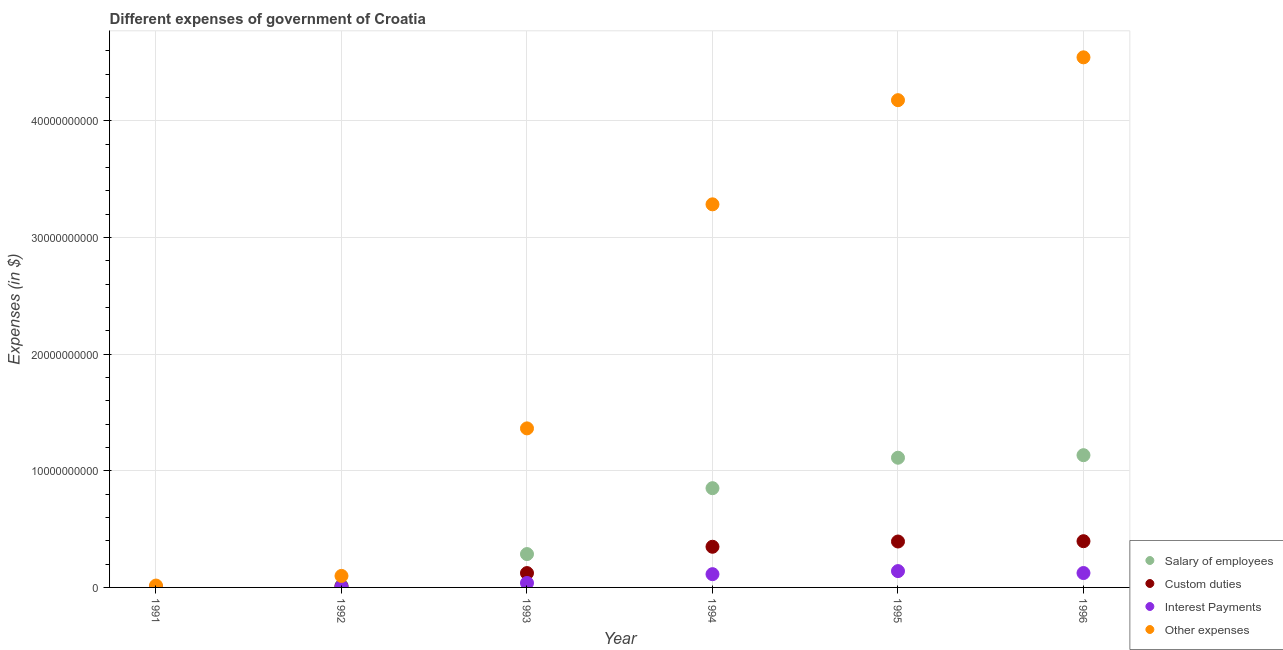How many different coloured dotlines are there?
Make the answer very short. 4. Is the number of dotlines equal to the number of legend labels?
Your answer should be compact. Yes. What is the amount spent on salary of employees in 1993?
Offer a very short reply. 2.86e+09. Across all years, what is the maximum amount spent on interest payments?
Keep it short and to the point. 1.40e+09. Across all years, what is the minimum amount spent on custom duties?
Your response must be concise. 5.01e+06. In which year was the amount spent on custom duties maximum?
Your answer should be very brief. 1996. What is the total amount spent on interest payments in the graph?
Offer a very short reply. 4.22e+09. What is the difference between the amount spent on other expenses in 1995 and that in 1996?
Offer a terse response. -3.67e+09. What is the difference between the amount spent on salary of employees in 1994 and the amount spent on custom duties in 1992?
Offer a very short reply. 8.41e+09. What is the average amount spent on other expenses per year?
Provide a short and direct response. 2.25e+1. In the year 1995, what is the difference between the amount spent on custom duties and amount spent on interest payments?
Your response must be concise. 2.54e+09. What is the ratio of the amount spent on salary of employees in 1994 to that in 1996?
Give a very brief answer. 0.75. Is the difference between the amount spent on other expenses in 1995 and 1996 greater than the difference between the amount spent on salary of employees in 1995 and 1996?
Your answer should be very brief. No. What is the difference between the highest and the second highest amount spent on custom duties?
Offer a terse response. 2.74e+07. What is the difference between the highest and the lowest amount spent on other expenses?
Ensure brevity in your answer.  4.53e+1. In how many years, is the amount spent on other expenses greater than the average amount spent on other expenses taken over all years?
Give a very brief answer. 3. Is the sum of the amount spent on salary of employees in 1992 and 1993 greater than the maximum amount spent on interest payments across all years?
Offer a terse response. Yes. Is it the case that in every year, the sum of the amount spent on salary of employees and amount spent on custom duties is greater than the amount spent on interest payments?
Your answer should be compact. Yes. Does the amount spent on salary of employees monotonically increase over the years?
Your answer should be compact. Yes. Is the amount spent on custom duties strictly less than the amount spent on salary of employees over the years?
Make the answer very short. Yes. How many years are there in the graph?
Your answer should be very brief. 6. Does the graph contain any zero values?
Provide a short and direct response. No. Where does the legend appear in the graph?
Make the answer very short. Bottom right. How are the legend labels stacked?
Keep it short and to the point. Vertical. What is the title of the graph?
Your answer should be compact. Different expenses of government of Croatia. What is the label or title of the X-axis?
Your response must be concise. Year. What is the label or title of the Y-axis?
Your response must be concise. Expenses (in $). What is the Expenses (in $) of Salary of employees in 1991?
Keep it short and to the point. 3.65e+07. What is the Expenses (in $) in Custom duties in 1991?
Provide a succinct answer. 5.01e+06. What is the Expenses (in $) of Interest Payments in 1991?
Offer a very short reply. 6.00e+05. What is the Expenses (in $) in Other expenses in 1991?
Make the answer very short. 1.61e+08. What is the Expenses (in $) in Salary of employees in 1992?
Your answer should be very brief. 1.59e+08. What is the Expenses (in $) in Custom duties in 1992?
Give a very brief answer. 9.94e+07. What is the Expenses (in $) of Interest Payments in 1992?
Your answer should be very brief. 6.43e+07. What is the Expenses (in $) in Other expenses in 1992?
Keep it short and to the point. 9.87e+08. What is the Expenses (in $) in Salary of employees in 1993?
Your response must be concise. 2.86e+09. What is the Expenses (in $) of Custom duties in 1993?
Give a very brief answer. 1.23e+09. What is the Expenses (in $) of Interest Payments in 1993?
Your response must be concise. 3.82e+08. What is the Expenses (in $) of Other expenses in 1993?
Provide a succinct answer. 1.36e+1. What is the Expenses (in $) of Salary of employees in 1994?
Keep it short and to the point. 8.51e+09. What is the Expenses (in $) of Custom duties in 1994?
Offer a very short reply. 3.49e+09. What is the Expenses (in $) of Interest Payments in 1994?
Offer a very short reply. 1.14e+09. What is the Expenses (in $) in Other expenses in 1994?
Your answer should be compact. 3.29e+1. What is the Expenses (in $) in Salary of employees in 1995?
Your answer should be compact. 1.11e+1. What is the Expenses (in $) in Custom duties in 1995?
Your answer should be very brief. 3.94e+09. What is the Expenses (in $) of Interest Payments in 1995?
Make the answer very short. 1.40e+09. What is the Expenses (in $) of Other expenses in 1995?
Keep it short and to the point. 4.18e+1. What is the Expenses (in $) of Salary of employees in 1996?
Provide a short and direct response. 1.13e+1. What is the Expenses (in $) of Custom duties in 1996?
Provide a short and direct response. 3.96e+09. What is the Expenses (in $) in Interest Payments in 1996?
Provide a succinct answer. 1.23e+09. What is the Expenses (in $) of Other expenses in 1996?
Make the answer very short. 4.55e+1. Across all years, what is the maximum Expenses (in $) in Salary of employees?
Keep it short and to the point. 1.13e+1. Across all years, what is the maximum Expenses (in $) in Custom duties?
Provide a short and direct response. 3.96e+09. Across all years, what is the maximum Expenses (in $) in Interest Payments?
Make the answer very short. 1.40e+09. Across all years, what is the maximum Expenses (in $) in Other expenses?
Provide a short and direct response. 4.55e+1. Across all years, what is the minimum Expenses (in $) in Salary of employees?
Your response must be concise. 3.65e+07. Across all years, what is the minimum Expenses (in $) in Custom duties?
Your answer should be compact. 5.01e+06. Across all years, what is the minimum Expenses (in $) of Other expenses?
Make the answer very short. 1.61e+08. What is the total Expenses (in $) in Salary of employees in the graph?
Ensure brevity in your answer.  3.40e+1. What is the total Expenses (in $) in Custom duties in the graph?
Ensure brevity in your answer.  1.27e+1. What is the total Expenses (in $) in Interest Payments in the graph?
Keep it short and to the point. 4.22e+09. What is the total Expenses (in $) of Other expenses in the graph?
Your response must be concise. 1.35e+11. What is the difference between the Expenses (in $) of Salary of employees in 1991 and that in 1992?
Your answer should be very brief. -1.23e+08. What is the difference between the Expenses (in $) in Custom duties in 1991 and that in 1992?
Provide a short and direct response. -9.44e+07. What is the difference between the Expenses (in $) in Interest Payments in 1991 and that in 1992?
Keep it short and to the point. -6.37e+07. What is the difference between the Expenses (in $) in Other expenses in 1991 and that in 1992?
Make the answer very short. -8.26e+08. What is the difference between the Expenses (in $) of Salary of employees in 1991 and that in 1993?
Provide a succinct answer. -2.82e+09. What is the difference between the Expenses (in $) in Custom duties in 1991 and that in 1993?
Offer a terse response. -1.23e+09. What is the difference between the Expenses (in $) in Interest Payments in 1991 and that in 1993?
Give a very brief answer. -3.81e+08. What is the difference between the Expenses (in $) of Other expenses in 1991 and that in 1993?
Make the answer very short. -1.35e+1. What is the difference between the Expenses (in $) of Salary of employees in 1991 and that in 1994?
Offer a very short reply. -8.47e+09. What is the difference between the Expenses (in $) of Custom duties in 1991 and that in 1994?
Give a very brief answer. -3.48e+09. What is the difference between the Expenses (in $) in Interest Payments in 1991 and that in 1994?
Ensure brevity in your answer.  -1.14e+09. What is the difference between the Expenses (in $) in Other expenses in 1991 and that in 1994?
Your answer should be very brief. -3.27e+1. What is the difference between the Expenses (in $) of Salary of employees in 1991 and that in 1995?
Your response must be concise. -1.11e+1. What is the difference between the Expenses (in $) of Custom duties in 1991 and that in 1995?
Keep it short and to the point. -3.93e+09. What is the difference between the Expenses (in $) of Interest Payments in 1991 and that in 1995?
Make the answer very short. -1.40e+09. What is the difference between the Expenses (in $) in Other expenses in 1991 and that in 1995?
Provide a succinct answer. -4.16e+1. What is the difference between the Expenses (in $) in Salary of employees in 1991 and that in 1996?
Offer a terse response. -1.13e+1. What is the difference between the Expenses (in $) of Custom duties in 1991 and that in 1996?
Keep it short and to the point. -3.96e+09. What is the difference between the Expenses (in $) in Interest Payments in 1991 and that in 1996?
Make the answer very short. -1.23e+09. What is the difference between the Expenses (in $) in Other expenses in 1991 and that in 1996?
Ensure brevity in your answer.  -4.53e+1. What is the difference between the Expenses (in $) of Salary of employees in 1992 and that in 1993?
Ensure brevity in your answer.  -2.70e+09. What is the difference between the Expenses (in $) in Custom duties in 1992 and that in 1993?
Give a very brief answer. -1.13e+09. What is the difference between the Expenses (in $) in Interest Payments in 1992 and that in 1993?
Provide a short and direct response. -3.18e+08. What is the difference between the Expenses (in $) in Other expenses in 1992 and that in 1993?
Offer a very short reply. -1.27e+1. What is the difference between the Expenses (in $) in Salary of employees in 1992 and that in 1994?
Your response must be concise. -8.35e+09. What is the difference between the Expenses (in $) of Custom duties in 1992 and that in 1994?
Your response must be concise. -3.39e+09. What is the difference between the Expenses (in $) in Interest Payments in 1992 and that in 1994?
Make the answer very short. -1.07e+09. What is the difference between the Expenses (in $) of Other expenses in 1992 and that in 1994?
Make the answer very short. -3.19e+1. What is the difference between the Expenses (in $) of Salary of employees in 1992 and that in 1995?
Give a very brief answer. -1.10e+1. What is the difference between the Expenses (in $) of Custom duties in 1992 and that in 1995?
Offer a terse response. -3.84e+09. What is the difference between the Expenses (in $) of Interest Payments in 1992 and that in 1995?
Your answer should be compact. -1.34e+09. What is the difference between the Expenses (in $) of Other expenses in 1992 and that in 1995?
Give a very brief answer. -4.08e+1. What is the difference between the Expenses (in $) in Salary of employees in 1992 and that in 1996?
Offer a terse response. -1.12e+1. What is the difference between the Expenses (in $) of Custom duties in 1992 and that in 1996?
Your response must be concise. -3.87e+09. What is the difference between the Expenses (in $) of Interest Payments in 1992 and that in 1996?
Your response must be concise. -1.17e+09. What is the difference between the Expenses (in $) in Other expenses in 1992 and that in 1996?
Offer a terse response. -4.45e+1. What is the difference between the Expenses (in $) of Salary of employees in 1993 and that in 1994?
Offer a terse response. -5.65e+09. What is the difference between the Expenses (in $) of Custom duties in 1993 and that in 1994?
Offer a terse response. -2.26e+09. What is the difference between the Expenses (in $) in Interest Payments in 1993 and that in 1994?
Provide a short and direct response. -7.55e+08. What is the difference between the Expenses (in $) of Other expenses in 1993 and that in 1994?
Provide a succinct answer. -1.92e+1. What is the difference between the Expenses (in $) of Salary of employees in 1993 and that in 1995?
Keep it short and to the point. -8.26e+09. What is the difference between the Expenses (in $) of Custom duties in 1993 and that in 1995?
Your response must be concise. -2.71e+09. What is the difference between the Expenses (in $) in Interest Payments in 1993 and that in 1995?
Give a very brief answer. -1.02e+09. What is the difference between the Expenses (in $) in Other expenses in 1993 and that in 1995?
Provide a short and direct response. -2.81e+1. What is the difference between the Expenses (in $) in Salary of employees in 1993 and that in 1996?
Your response must be concise. -8.48e+09. What is the difference between the Expenses (in $) of Custom duties in 1993 and that in 1996?
Your response must be concise. -2.73e+09. What is the difference between the Expenses (in $) in Interest Payments in 1993 and that in 1996?
Your answer should be compact. -8.53e+08. What is the difference between the Expenses (in $) in Other expenses in 1993 and that in 1996?
Keep it short and to the point. -3.18e+1. What is the difference between the Expenses (in $) in Salary of employees in 1994 and that in 1995?
Your response must be concise. -2.61e+09. What is the difference between the Expenses (in $) of Custom duties in 1994 and that in 1995?
Your response must be concise. -4.51e+08. What is the difference between the Expenses (in $) of Interest Payments in 1994 and that in 1995?
Provide a short and direct response. -2.63e+08. What is the difference between the Expenses (in $) of Other expenses in 1994 and that in 1995?
Ensure brevity in your answer.  -8.93e+09. What is the difference between the Expenses (in $) in Salary of employees in 1994 and that in 1996?
Your answer should be compact. -2.83e+09. What is the difference between the Expenses (in $) in Custom duties in 1994 and that in 1996?
Provide a short and direct response. -4.78e+08. What is the difference between the Expenses (in $) in Interest Payments in 1994 and that in 1996?
Your answer should be compact. -9.75e+07. What is the difference between the Expenses (in $) of Other expenses in 1994 and that in 1996?
Your response must be concise. -1.26e+1. What is the difference between the Expenses (in $) of Salary of employees in 1995 and that in 1996?
Keep it short and to the point. -2.18e+08. What is the difference between the Expenses (in $) in Custom duties in 1995 and that in 1996?
Provide a succinct answer. -2.74e+07. What is the difference between the Expenses (in $) in Interest Payments in 1995 and that in 1996?
Ensure brevity in your answer.  1.66e+08. What is the difference between the Expenses (in $) in Other expenses in 1995 and that in 1996?
Ensure brevity in your answer.  -3.67e+09. What is the difference between the Expenses (in $) in Salary of employees in 1991 and the Expenses (in $) in Custom duties in 1992?
Ensure brevity in your answer.  -6.29e+07. What is the difference between the Expenses (in $) in Salary of employees in 1991 and the Expenses (in $) in Interest Payments in 1992?
Give a very brief answer. -2.78e+07. What is the difference between the Expenses (in $) of Salary of employees in 1991 and the Expenses (in $) of Other expenses in 1992?
Your answer should be very brief. -9.50e+08. What is the difference between the Expenses (in $) in Custom duties in 1991 and the Expenses (in $) in Interest Payments in 1992?
Your answer should be compact. -5.93e+07. What is the difference between the Expenses (in $) in Custom duties in 1991 and the Expenses (in $) in Other expenses in 1992?
Provide a short and direct response. -9.82e+08. What is the difference between the Expenses (in $) of Interest Payments in 1991 and the Expenses (in $) of Other expenses in 1992?
Offer a very short reply. -9.86e+08. What is the difference between the Expenses (in $) in Salary of employees in 1991 and the Expenses (in $) in Custom duties in 1993?
Offer a terse response. -1.19e+09. What is the difference between the Expenses (in $) in Salary of employees in 1991 and the Expenses (in $) in Interest Payments in 1993?
Provide a succinct answer. -3.45e+08. What is the difference between the Expenses (in $) in Salary of employees in 1991 and the Expenses (in $) in Other expenses in 1993?
Offer a very short reply. -1.36e+1. What is the difference between the Expenses (in $) in Custom duties in 1991 and the Expenses (in $) in Interest Payments in 1993?
Make the answer very short. -3.77e+08. What is the difference between the Expenses (in $) in Custom duties in 1991 and the Expenses (in $) in Other expenses in 1993?
Your answer should be very brief. -1.36e+1. What is the difference between the Expenses (in $) of Interest Payments in 1991 and the Expenses (in $) of Other expenses in 1993?
Provide a succinct answer. -1.36e+1. What is the difference between the Expenses (in $) in Salary of employees in 1991 and the Expenses (in $) in Custom duties in 1994?
Your answer should be very brief. -3.45e+09. What is the difference between the Expenses (in $) in Salary of employees in 1991 and the Expenses (in $) in Interest Payments in 1994?
Keep it short and to the point. -1.10e+09. What is the difference between the Expenses (in $) in Salary of employees in 1991 and the Expenses (in $) in Other expenses in 1994?
Keep it short and to the point. -3.28e+1. What is the difference between the Expenses (in $) in Custom duties in 1991 and the Expenses (in $) in Interest Payments in 1994?
Your answer should be compact. -1.13e+09. What is the difference between the Expenses (in $) in Custom duties in 1991 and the Expenses (in $) in Other expenses in 1994?
Your response must be concise. -3.28e+1. What is the difference between the Expenses (in $) in Interest Payments in 1991 and the Expenses (in $) in Other expenses in 1994?
Your response must be concise. -3.29e+1. What is the difference between the Expenses (in $) of Salary of employees in 1991 and the Expenses (in $) of Custom duties in 1995?
Make the answer very short. -3.90e+09. What is the difference between the Expenses (in $) of Salary of employees in 1991 and the Expenses (in $) of Interest Payments in 1995?
Your answer should be very brief. -1.36e+09. What is the difference between the Expenses (in $) of Salary of employees in 1991 and the Expenses (in $) of Other expenses in 1995?
Keep it short and to the point. -4.17e+1. What is the difference between the Expenses (in $) in Custom duties in 1991 and the Expenses (in $) in Interest Payments in 1995?
Your response must be concise. -1.40e+09. What is the difference between the Expenses (in $) in Custom duties in 1991 and the Expenses (in $) in Other expenses in 1995?
Offer a terse response. -4.18e+1. What is the difference between the Expenses (in $) of Interest Payments in 1991 and the Expenses (in $) of Other expenses in 1995?
Provide a succinct answer. -4.18e+1. What is the difference between the Expenses (in $) in Salary of employees in 1991 and the Expenses (in $) in Custom duties in 1996?
Your answer should be very brief. -3.93e+09. What is the difference between the Expenses (in $) in Salary of employees in 1991 and the Expenses (in $) in Interest Payments in 1996?
Your response must be concise. -1.20e+09. What is the difference between the Expenses (in $) of Salary of employees in 1991 and the Expenses (in $) of Other expenses in 1996?
Provide a succinct answer. -4.54e+1. What is the difference between the Expenses (in $) of Custom duties in 1991 and the Expenses (in $) of Interest Payments in 1996?
Ensure brevity in your answer.  -1.23e+09. What is the difference between the Expenses (in $) in Custom duties in 1991 and the Expenses (in $) in Other expenses in 1996?
Provide a short and direct response. -4.55e+1. What is the difference between the Expenses (in $) in Interest Payments in 1991 and the Expenses (in $) in Other expenses in 1996?
Give a very brief answer. -4.55e+1. What is the difference between the Expenses (in $) in Salary of employees in 1992 and the Expenses (in $) in Custom duties in 1993?
Your answer should be very brief. -1.07e+09. What is the difference between the Expenses (in $) in Salary of employees in 1992 and the Expenses (in $) in Interest Payments in 1993?
Your answer should be compact. -2.23e+08. What is the difference between the Expenses (in $) of Salary of employees in 1992 and the Expenses (in $) of Other expenses in 1993?
Your answer should be very brief. -1.35e+1. What is the difference between the Expenses (in $) in Custom duties in 1992 and the Expenses (in $) in Interest Payments in 1993?
Offer a terse response. -2.82e+08. What is the difference between the Expenses (in $) in Custom duties in 1992 and the Expenses (in $) in Other expenses in 1993?
Ensure brevity in your answer.  -1.35e+1. What is the difference between the Expenses (in $) in Interest Payments in 1992 and the Expenses (in $) in Other expenses in 1993?
Make the answer very short. -1.36e+1. What is the difference between the Expenses (in $) in Salary of employees in 1992 and the Expenses (in $) in Custom duties in 1994?
Keep it short and to the point. -3.33e+09. What is the difference between the Expenses (in $) in Salary of employees in 1992 and the Expenses (in $) in Interest Payments in 1994?
Provide a short and direct response. -9.78e+08. What is the difference between the Expenses (in $) in Salary of employees in 1992 and the Expenses (in $) in Other expenses in 1994?
Your answer should be very brief. -3.27e+1. What is the difference between the Expenses (in $) in Custom duties in 1992 and the Expenses (in $) in Interest Payments in 1994?
Give a very brief answer. -1.04e+09. What is the difference between the Expenses (in $) in Custom duties in 1992 and the Expenses (in $) in Other expenses in 1994?
Make the answer very short. -3.28e+1. What is the difference between the Expenses (in $) of Interest Payments in 1992 and the Expenses (in $) of Other expenses in 1994?
Offer a terse response. -3.28e+1. What is the difference between the Expenses (in $) in Salary of employees in 1992 and the Expenses (in $) in Custom duties in 1995?
Your response must be concise. -3.78e+09. What is the difference between the Expenses (in $) in Salary of employees in 1992 and the Expenses (in $) in Interest Payments in 1995?
Your answer should be compact. -1.24e+09. What is the difference between the Expenses (in $) in Salary of employees in 1992 and the Expenses (in $) in Other expenses in 1995?
Make the answer very short. -4.16e+1. What is the difference between the Expenses (in $) of Custom duties in 1992 and the Expenses (in $) of Interest Payments in 1995?
Provide a short and direct response. -1.30e+09. What is the difference between the Expenses (in $) of Custom duties in 1992 and the Expenses (in $) of Other expenses in 1995?
Your answer should be very brief. -4.17e+1. What is the difference between the Expenses (in $) of Interest Payments in 1992 and the Expenses (in $) of Other expenses in 1995?
Provide a succinct answer. -4.17e+1. What is the difference between the Expenses (in $) of Salary of employees in 1992 and the Expenses (in $) of Custom duties in 1996?
Make the answer very short. -3.81e+09. What is the difference between the Expenses (in $) of Salary of employees in 1992 and the Expenses (in $) of Interest Payments in 1996?
Provide a short and direct response. -1.08e+09. What is the difference between the Expenses (in $) of Salary of employees in 1992 and the Expenses (in $) of Other expenses in 1996?
Provide a short and direct response. -4.53e+1. What is the difference between the Expenses (in $) of Custom duties in 1992 and the Expenses (in $) of Interest Payments in 1996?
Your answer should be very brief. -1.14e+09. What is the difference between the Expenses (in $) of Custom duties in 1992 and the Expenses (in $) of Other expenses in 1996?
Give a very brief answer. -4.54e+1. What is the difference between the Expenses (in $) in Interest Payments in 1992 and the Expenses (in $) in Other expenses in 1996?
Keep it short and to the point. -4.54e+1. What is the difference between the Expenses (in $) in Salary of employees in 1993 and the Expenses (in $) in Custom duties in 1994?
Your response must be concise. -6.27e+08. What is the difference between the Expenses (in $) in Salary of employees in 1993 and the Expenses (in $) in Interest Payments in 1994?
Keep it short and to the point. 1.72e+09. What is the difference between the Expenses (in $) in Salary of employees in 1993 and the Expenses (in $) in Other expenses in 1994?
Keep it short and to the point. -3.00e+1. What is the difference between the Expenses (in $) of Custom duties in 1993 and the Expenses (in $) of Interest Payments in 1994?
Offer a very short reply. 9.32e+07. What is the difference between the Expenses (in $) in Custom duties in 1993 and the Expenses (in $) in Other expenses in 1994?
Offer a very short reply. -3.16e+1. What is the difference between the Expenses (in $) in Interest Payments in 1993 and the Expenses (in $) in Other expenses in 1994?
Your answer should be very brief. -3.25e+1. What is the difference between the Expenses (in $) of Salary of employees in 1993 and the Expenses (in $) of Custom duties in 1995?
Provide a succinct answer. -1.08e+09. What is the difference between the Expenses (in $) of Salary of employees in 1993 and the Expenses (in $) of Interest Payments in 1995?
Offer a terse response. 1.46e+09. What is the difference between the Expenses (in $) in Salary of employees in 1993 and the Expenses (in $) in Other expenses in 1995?
Your response must be concise. -3.89e+1. What is the difference between the Expenses (in $) of Custom duties in 1993 and the Expenses (in $) of Interest Payments in 1995?
Make the answer very short. -1.70e+08. What is the difference between the Expenses (in $) in Custom duties in 1993 and the Expenses (in $) in Other expenses in 1995?
Make the answer very short. -4.06e+1. What is the difference between the Expenses (in $) in Interest Payments in 1993 and the Expenses (in $) in Other expenses in 1995?
Your answer should be compact. -4.14e+1. What is the difference between the Expenses (in $) of Salary of employees in 1993 and the Expenses (in $) of Custom duties in 1996?
Make the answer very short. -1.10e+09. What is the difference between the Expenses (in $) of Salary of employees in 1993 and the Expenses (in $) of Interest Payments in 1996?
Your answer should be very brief. 1.63e+09. What is the difference between the Expenses (in $) of Salary of employees in 1993 and the Expenses (in $) of Other expenses in 1996?
Offer a very short reply. -4.26e+1. What is the difference between the Expenses (in $) in Custom duties in 1993 and the Expenses (in $) in Interest Payments in 1996?
Your response must be concise. -4.30e+06. What is the difference between the Expenses (in $) of Custom duties in 1993 and the Expenses (in $) of Other expenses in 1996?
Keep it short and to the point. -4.42e+1. What is the difference between the Expenses (in $) in Interest Payments in 1993 and the Expenses (in $) in Other expenses in 1996?
Make the answer very short. -4.51e+1. What is the difference between the Expenses (in $) of Salary of employees in 1994 and the Expenses (in $) of Custom duties in 1995?
Give a very brief answer. 4.57e+09. What is the difference between the Expenses (in $) of Salary of employees in 1994 and the Expenses (in $) of Interest Payments in 1995?
Provide a succinct answer. 7.11e+09. What is the difference between the Expenses (in $) in Salary of employees in 1994 and the Expenses (in $) in Other expenses in 1995?
Make the answer very short. -3.33e+1. What is the difference between the Expenses (in $) in Custom duties in 1994 and the Expenses (in $) in Interest Payments in 1995?
Give a very brief answer. 2.09e+09. What is the difference between the Expenses (in $) of Custom duties in 1994 and the Expenses (in $) of Other expenses in 1995?
Your answer should be compact. -3.83e+1. What is the difference between the Expenses (in $) in Interest Payments in 1994 and the Expenses (in $) in Other expenses in 1995?
Your response must be concise. -4.06e+1. What is the difference between the Expenses (in $) in Salary of employees in 1994 and the Expenses (in $) in Custom duties in 1996?
Offer a very short reply. 4.55e+09. What is the difference between the Expenses (in $) in Salary of employees in 1994 and the Expenses (in $) in Interest Payments in 1996?
Your response must be concise. 7.28e+09. What is the difference between the Expenses (in $) in Salary of employees in 1994 and the Expenses (in $) in Other expenses in 1996?
Your response must be concise. -3.69e+1. What is the difference between the Expenses (in $) of Custom duties in 1994 and the Expenses (in $) of Interest Payments in 1996?
Keep it short and to the point. 2.25e+09. What is the difference between the Expenses (in $) of Custom duties in 1994 and the Expenses (in $) of Other expenses in 1996?
Give a very brief answer. -4.20e+1. What is the difference between the Expenses (in $) in Interest Payments in 1994 and the Expenses (in $) in Other expenses in 1996?
Your response must be concise. -4.43e+1. What is the difference between the Expenses (in $) of Salary of employees in 1995 and the Expenses (in $) of Custom duties in 1996?
Your answer should be very brief. 7.16e+09. What is the difference between the Expenses (in $) in Salary of employees in 1995 and the Expenses (in $) in Interest Payments in 1996?
Your answer should be very brief. 9.89e+09. What is the difference between the Expenses (in $) in Salary of employees in 1995 and the Expenses (in $) in Other expenses in 1996?
Your answer should be compact. -3.43e+1. What is the difference between the Expenses (in $) of Custom duties in 1995 and the Expenses (in $) of Interest Payments in 1996?
Your response must be concise. 2.70e+09. What is the difference between the Expenses (in $) of Custom duties in 1995 and the Expenses (in $) of Other expenses in 1996?
Provide a short and direct response. -4.15e+1. What is the difference between the Expenses (in $) in Interest Payments in 1995 and the Expenses (in $) in Other expenses in 1996?
Your answer should be very brief. -4.41e+1. What is the average Expenses (in $) in Salary of employees per year?
Make the answer very short. 5.67e+09. What is the average Expenses (in $) of Custom duties per year?
Your answer should be compact. 2.12e+09. What is the average Expenses (in $) of Interest Payments per year?
Ensure brevity in your answer.  7.03e+08. What is the average Expenses (in $) in Other expenses per year?
Give a very brief answer. 2.25e+1. In the year 1991, what is the difference between the Expenses (in $) in Salary of employees and Expenses (in $) in Custom duties?
Your response must be concise. 3.15e+07. In the year 1991, what is the difference between the Expenses (in $) in Salary of employees and Expenses (in $) in Interest Payments?
Your answer should be very brief. 3.59e+07. In the year 1991, what is the difference between the Expenses (in $) in Salary of employees and Expenses (in $) in Other expenses?
Provide a short and direct response. -1.24e+08. In the year 1991, what is the difference between the Expenses (in $) in Custom duties and Expenses (in $) in Interest Payments?
Give a very brief answer. 4.41e+06. In the year 1991, what is the difference between the Expenses (in $) of Custom duties and Expenses (in $) of Other expenses?
Offer a terse response. -1.56e+08. In the year 1991, what is the difference between the Expenses (in $) in Interest Payments and Expenses (in $) in Other expenses?
Offer a very short reply. -1.60e+08. In the year 1992, what is the difference between the Expenses (in $) in Salary of employees and Expenses (in $) in Custom duties?
Make the answer very short. 5.98e+07. In the year 1992, what is the difference between the Expenses (in $) of Salary of employees and Expenses (in $) of Interest Payments?
Give a very brief answer. 9.49e+07. In the year 1992, what is the difference between the Expenses (in $) of Salary of employees and Expenses (in $) of Other expenses?
Offer a very short reply. -8.28e+08. In the year 1992, what is the difference between the Expenses (in $) in Custom duties and Expenses (in $) in Interest Payments?
Offer a very short reply. 3.52e+07. In the year 1992, what is the difference between the Expenses (in $) in Custom duties and Expenses (in $) in Other expenses?
Your answer should be very brief. -8.87e+08. In the year 1992, what is the difference between the Expenses (in $) in Interest Payments and Expenses (in $) in Other expenses?
Ensure brevity in your answer.  -9.22e+08. In the year 1993, what is the difference between the Expenses (in $) of Salary of employees and Expenses (in $) of Custom duties?
Your response must be concise. 1.63e+09. In the year 1993, what is the difference between the Expenses (in $) in Salary of employees and Expenses (in $) in Interest Payments?
Offer a terse response. 2.48e+09. In the year 1993, what is the difference between the Expenses (in $) in Salary of employees and Expenses (in $) in Other expenses?
Provide a succinct answer. -1.08e+1. In the year 1993, what is the difference between the Expenses (in $) in Custom duties and Expenses (in $) in Interest Payments?
Your answer should be compact. 8.48e+08. In the year 1993, what is the difference between the Expenses (in $) in Custom duties and Expenses (in $) in Other expenses?
Make the answer very short. -1.24e+1. In the year 1993, what is the difference between the Expenses (in $) of Interest Payments and Expenses (in $) of Other expenses?
Make the answer very short. -1.33e+1. In the year 1994, what is the difference between the Expenses (in $) in Salary of employees and Expenses (in $) in Custom duties?
Your answer should be compact. 5.02e+09. In the year 1994, what is the difference between the Expenses (in $) of Salary of employees and Expenses (in $) of Interest Payments?
Make the answer very short. 7.37e+09. In the year 1994, what is the difference between the Expenses (in $) of Salary of employees and Expenses (in $) of Other expenses?
Your response must be concise. -2.43e+1. In the year 1994, what is the difference between the Expenses (in $) in Custom duties and Expenses (in $) in Interest Payments?
Make the answer very short. 2.35e+09. In the year 1994, what is the difference between the Expenses (in $) of Custom duties and Expenses (in $) of Other expenses?
Offer a terse response. -2.94e+1. In the year 1994, what is the difference between the Expenses (in $) in Interest Payments and Expenses (in $) in Other expenses?
Give a very brief answer. -3.17e+1. In the year 1995, what is the difference between the Expenses (in $) in Salary of employees and Expenses (in $) in Custom duties?
Offer a terse response. 7.18e+09. In the year 1995, what is the difference between the Expenses (in $) in Salary of employees and Expenses (in $) in Interest Payments?
Your response must be concise. 9.72e+09. In the year 1995, what is the difference between the Expenses (in $) in Salary of employees and Expenses (in $) in Other expenses?
Your response must be concise. -3.07e+1. In the year 1995, what is the difference between the Expenses (in $) of Custom duties and Expenses (in $) of Interest Payments?
Offer a very short reply. 2.54e+09. In the year 1995, what is the difference between the Expenses (in $) in Custom duties and Expenses (in $) in Other expenses?
Provide a succinct answer. -3.78e+1. In the year 1995, what is the difference between the Expenses (in $) of Interest Payments and Expenses (in $) of Other expenses?
Give a very brief answer. -4.04e+1. In the year 1996, what is the difference between the Expenses (in $) of Salary of employees and Expenses (in $) of Custom duties?
Ensure brevity in your answer.  7.38e+09. In the year 1996, what is the difference between the Expenses (in $) of Salary of employees and Expenses (in $) of Interest Payments?
Make the answer very short. 1.01e+1. In the year 1996, what is the difference between the Expenses (in $) in Salary of employees and Expenses (in $) in Other expenses?
Provide a short and direct response. -3.41e+1. In the year 1996, what is the difference between the Expenses (in $) in Custom duties and Expenses (in $) in Interest Payments?
Your answer should be compact. 2.73e+09. In the year 1996, what is the difference between the Expenses (in $) in Custom duties and Expenses (in $) in Other expenses?
Give a very brief answer. -4.15e+1. In the year 1996, what is the difference between the Expenses (in $) in Interest Payments and Expenses (in $) in Other expenses?
Your answer should be very brief. -4.42e+1. What is the ratio of the Expenses (in $) in Salary of employees in 1991 to that in 1992?
Make the answer very short. 0.23. What is the ratio of the Expenses (in $) in Custom duties in 1991 to that in 1992?
Your answer should be compact. 0.05. What is the ratio of the Expenses (in $) in Interest Payments in 1991 to that in 1992?
Provide a succinct answer. 0.01. What is the ratio of the Expenses (in $) in Other expenses in 1991 to that in 1992?
Ensure brevity in your answer.  0.16. What is the ratio of the Expenses (in $) of Salary of employees in 1991 to that in 1993?
Provide a short and direct response. 0.01. What is the ratio of the Expenses (in $) in Custom duties in 1991 to that in 1993?
Your answer should be compact. 0. What is the ratio of the Expenses (in $) of Interest Payments in 1991 to that in 1993?
Your answer should be very brief. 0. What is the ratio of the Expenses (in $) of Other expenses in 1991 to that in 1993?
Provide a short and direct response. 0.01. What is the ratio of the Expenses (in $) in Salary of employees in 1991 to that in 1994?
Ensure brevity in your answer.  0. What is the ratio of the Expenses (in $) of Custom duties in 1991 to that in 1994?
Give a very brief answer. 0. What is the ratio of the Expenses (in $) of Other expenses in 1991 to that in 1994?
Your response must be concise. 0. What is the ratio of the Expenses (in $) in Salary of employees in 1991 to that in 1995?
Provide a short and direct response. 0. What is the ratio of the Expenses (in $) in Custom duties in 1991 to that in 1995?
Provide a succinct answer. 0. What is the ratio of the Expenses (in $) in Interest Payments in 1991 to that in 1995?
Provide a succinct answer. 0. What is the ratio of the Expenses (in $) in Other expenses in 1991 to that in 1995?
Your answer should be very brief. 0. What is the ratio of the Expenses (in $) of Salary of employees in 1991 to that in 1996?
Offer a very short reply. 0. What is the ratio of the Expenses (in $) in Custom duties in 1991 to that in 1996?
Your answer should be compact. 0. What is the ratio of the Expenses (in $) of Interest Payments in 1991 to that in 1996?
Your answer should be very brief. 0. What is the ratio of the Expenses (in $) of Other expenses in 1991 to that in 1996?
Give a very brief answer. 0. What is the ratio of the Expenses (in $) in Salary of employees in 1992 to that in 1993?
Provide a succinct answer. 0.06. What is the ratio of the Expenses (in $) of Custom duties in 1992 to that in 1993?
Offer a very short reply. 0.08. What is the ratio of the Expenses (in $) of Interest Payments in 1992 to that in 1993?
Your answer should be compact. 0.17. What is the ratio of the Expenses (in $) in Other expenses in 1992 to that in 1993?
Your answer should be very brief. 0.07. What is the ratio of the Expenses (in $) of Salary of employees in 1992 to that in 1994?
Your answer should be compact. 0.02. What is the ratio of the Expenses (in $) in Custom duties in 1992 to that in 1994?
Provide a succinct answer. 0.03. What is the ratio of the Expenses (in $) of Interest Payments in 1992 to that in 1994?
Make the answer very short. 0.06. What is the ratio of the Expenses (in $) of Other expenses in 1992 to that in 1994?
Keep it short and to the point. 0.03. What is the ratio of the Expenses (in $) in Salary of employees in 1992 to that in 1995?
Your response must be concise. 0.01. What is the ratio of the Expenses (in $) in Custom duties in 1992 to that in 1995?
Your answer should be compact. 0.03. What is the ratio of the Expenses (in $) of Interest Payments in 1992 to that in 1995?
Your answer should be very brief. 0.05. What is the ratio of the Expenses (in $) in Other expenses in 1992 to that in 1995?
Provide a short and direct response. 0.02. What is the ratio of the Expenses (in $) in Salary of employees in 1992 to that in 1996?
Your response must be concise. 0.01. What is the ratio of the Expenses (in $) in Custom duties in 1992 to that in 1996?
Provide a short and direct response. 0.03. What is the ratio of the Expenses (in $) of Interest Payments in 1992 to that in 1996?
Your answer should be compact. 0.05. What is the ratio of the Expenses (in $) in Other expenses in 1992 to that in 1996?
Your answer should be compact. 0.02. What is the ratio of the Expenses (in $) in Salary of employees in 1993 to that in 1994?
Offer a very short reply. 0.34. What is the ratio of the Expenses (in $) in Custom duties in 1993 to that in 1994?
Provide a short and direct response. 0.35. What is the ratio of the Expenses (in $) in Interest Payments in 1993 to that in 1994?
Offer a very short reply. 0.34. What is the ratio of the Expenses (in $) in Other expenses in 1993 to that in 1994?
Offer a very short reply. 0.42. What is the ratio of the Expenses (in $) of Salary of employees in 1993 to that in 1995?
Ensure brevity in your answer.  0.26. What is the ratio of the Expenses (in $) of Custom duties in 1993 to that in 1995?
Your response must be concise. 0.31. What is the ratio of the Expenses (in $) of Interest Payments in 1993 to that in 1995?
Provide a succinct answer. 0.27. What is the ratio of the Expenses (in $) of Other expenses in 1993 to that in 1995?
Ensure brevity in your answer.  0.33. What is the ratio of the Expenses (in $) of Salary of employees in 1993 to that in 1996?
Your response must be concise. 0.25. What is the ratio of the Expenses (in $) in Custom duties in 1993 to that in 1996?
Make the answer very short. 0.31. What is the ratio of the Expenses (in $) in Interest Payments in 1993 to that in 1996?
Provide a succinct answer. 0.31. What is the ratio of the Expenses (in $) in Other expenses in 1993 to that in 1996?
Give a very brief answer. 0.3. What is the ratio of the Expenses (in $) in Salary of employees in 1994 to that in 1995?
Offer a terse response. 0.77. What is the ratio of the Expenses (in $) of Custom duties in 1994 to that in 1995?
Give a very brief answer. 0.89. What is the ratio of the Expenses (in $) in Interest Payments in 1994 to that in 1995?
Your answer should be compact. 0.81. What is the ratio of the Expenses (in $) in Other expenses in 1994 to that in 1995?
Your answer should be compact. 0.79. What is the ratio of the Expenses (in $) of Salary of employees in 1994 to that in 1996?
Provide a short and direct response. 0.75. What is the ratio of the Expenses (in $) of Custom duties in 1994 to that in 1996?
Your answer should be compact. 0.88. What is the ratio of the Expenses (in $) in Interest Payments in 1994 to that in 1996?
Your response must be concise. 0.92. What is the ratio of the Expenses (in $) in Other expenses in 1994 to that in 1996?
Provide a short and direct response. 0.72. What is the ratio of the Expenses (in $) of Salary of employees in 1995 to that in 1996?
Offer a terse response. 0.98. What is the ratio of the Expenses (in $) in Custom duties in 1995 to that in 1996?
Your response must be concise. 0.99. What is the ratio of the Expenses (in $) of Interest Payments in 1995 to that in 1996?
Your response must be concise. 1.13. What is the ratio of the Expenses (in $) of Other expenses in 1995 to that in 1996?
Provide a succinct answer. 0.92. What is the difference between the highest and the second highest Expenses (in $) in Salary of employees?
Your answer should be compact. 2.18e+08. What is the difference between the highest and the second highest Expenses (in $) of Custom duties?
Make the answer very short. 2.74e+07. What is the difference between the highest and the second highest Expenses (in $) of Interest Payments?
Make the answer very short. 1.66e+08. What is the difference between the highest and the second highest Expenses (in $) of Other expenses?
Provide a short and direct response. 3.67e+09. What is the difference between the highest and the lowest Expenses (in $) of Salary of employees?
Give a very brief answer. 1.13e+1. What is the difference between the highest and the lowest Expenses (in $) in Custom duties?
Offer a very short reply. 3.96e+09. What is the difference between the highest and the lowest Expenses (in $) of Interest Payments?
Make the answer very short. 1.40e+09. What is the difference between the highest and the lowest Expenses (in $) of Other expenses?
Your answer should be very brief. 4.53e+1. 